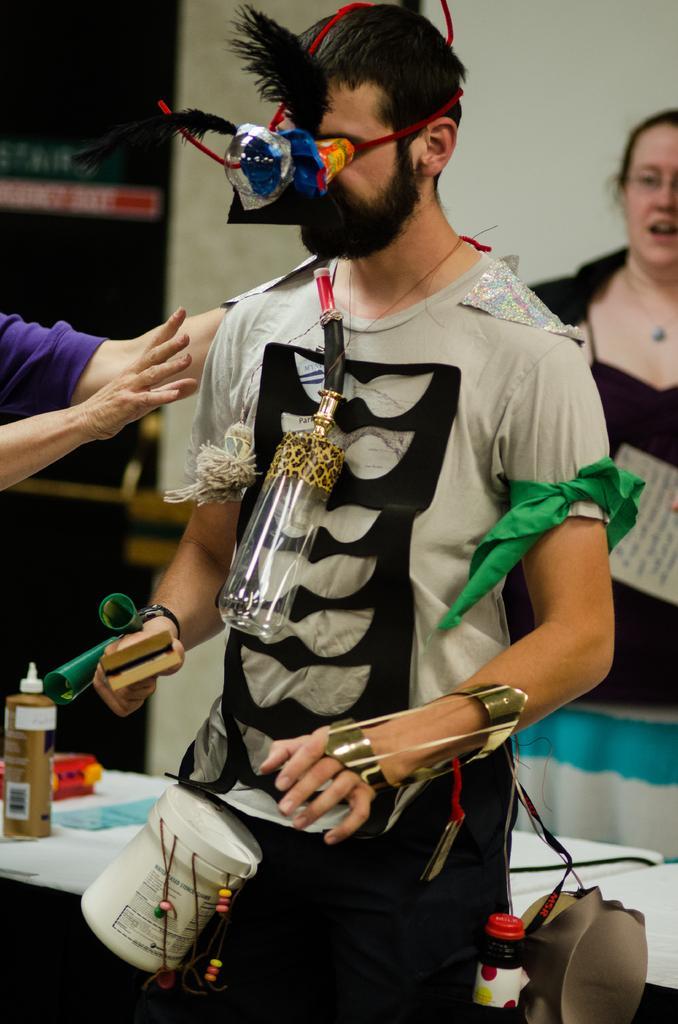Describe this image in one or two sentences. Here I can see a man wearing a t-shirt, mask and some other objects and standing. On the left side, I can see another person's hands. At the back of this man there is a table on which a bottle and some other objects are placed. On the right side there is a woman. In the background there is a wall. 